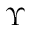Convert formula to latex. <formula><loc_0><loc_0><loc_500><loc_500>\Upsilon</formula> 